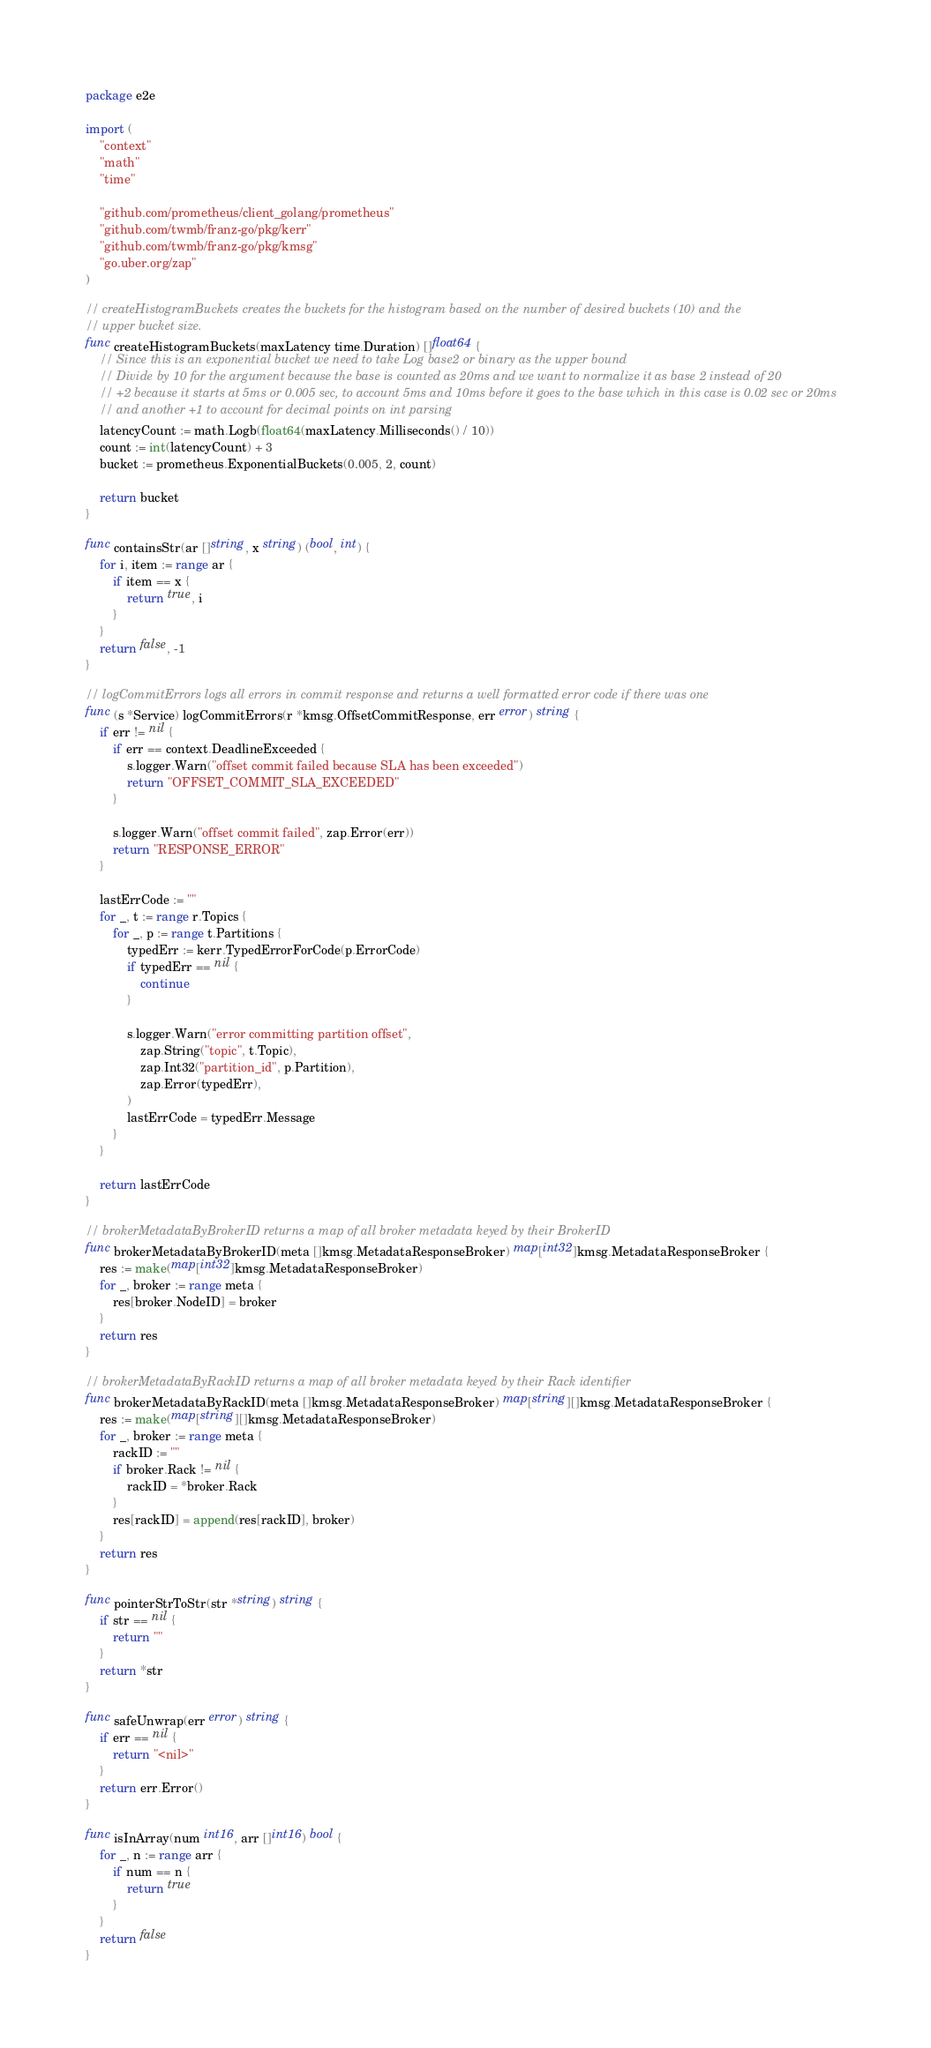Convert code to text. <code><loc_0><loc_0><loc_500><loc_500><_Go_>package e2e

import (
	"context"
	"math"
	"time"

	"github.com/prometheus/client_golang/prometheus"
	"github.com/twmb/franz-go/pkg/kerr"
	"github.com/twmb/franz-go/pkg/kmsg"
	"go.uber.org/zap"
)

// createHistogramBuckets creates the buckets for the histogram based on the number of desired buckets (10) and the
// upper bucket size.
func createHistogramBuckets(maxLatency time.Duration) []float64 {
	// Since this is an exponential bucket we need to take Log base2 or binary as the upper bound
	// Divide by 10 for the argument because the base is counted as 20ms and we want to normalize it as base 2 instead of 20
	// +2 because it starts at 5ms or 0.005 sec, to account 5ms and 10ms before it goes to the base which in this case is 0.02 sec or 20ms
	// and another +1 to account for decimal points on int parsing
	latencyCount := math.Logb(float64(maxLatency.Milliseconds() / 10))
	count := int(latencyCount) + 3
	bucket := prometheus.ExponentialBuckets(0.005, 2, count)

	return bucket
}

func containsStr(ar []string, x string) (bool, int) {
	for i, item := range ar {
		if item == x {
			return true, i
		}
	}
	return false, -1
}

// logCommitErrors logs all errors in commit response and returns a well formatted error code if there was one
func (s *Service) logCommitErrors(r *kmsg.OffsetCommitResponse, err error) string {
	if err != nil {
		if err == context.DeadlineExceeded {
			s.logger.Warn("offset commit failed because SLA has been exceeded")
			return "OFFSET_COMMIT_SLA_EXCEEDED"
		}

		s.logger.Warn("offset commit failed", zap.Error(err))
		return "RESPONSE_ERROR"
	}

	lastErrCode := ""
	for _, t := range r.Topics {
		for _, p := range t.Partitions {
			typedErr := kerr.TypedErrorForCode(p.ErrorCode)
			if typedErr == nil {
				continue
			}

			s.logger.Warn("error committing partition offset",
				zap.String("topic", t.Topic),
				zap.Int32("partition_id", p.Partition),
				zap.Error(typedErr),
			)
			lastErrCode = typedErr.Message
		}
	}

	return lastErrCode
}

// brokerMetadataByBrokerID returns a map of all broker metadata keyed by their BrokerID
func brokerMetadataByBrokerID(meta []kmsg.MetadataResponseBroker) map[int32]kmsg.MetadataResponseBroker {
	res := make(map[int32]kmsg.MetadataResponseBroker)
	for _, broker := range meta {
		res[broker.NodeID] = broker
	}
	return res
}

// brokerMetadataByRackID returns a map of all broker metadata keyed by their Rack identifier
func brokerMetadataByRackID(meta []kmsg.MetadataResponseBroker) map[string][]kmsg.MetadataResponseBroker {
	res := make(map[string][]kmsg.MetadataResponseBroker)
	for _, broker := range meta {
		rackID := ""
		if broker.Rack != nil {
			rackID = *broker.Rack
		}
		res[rackID] = append(res[rackID], broker)
	}
	return res
}

func pointerStrToStr(str *string) string {
	if str == nil {
		return ""
	}
	return *str
}

func safeUnwrap(err error) string {
	if err == nil {
		return "<nil>"
	}
	return err.Error()
}

func isInArray(num int16, arr []int16) bool {
	for _, n := range arr {
		if num == n {
			return true
		}
	}
	return false
}
</code> 